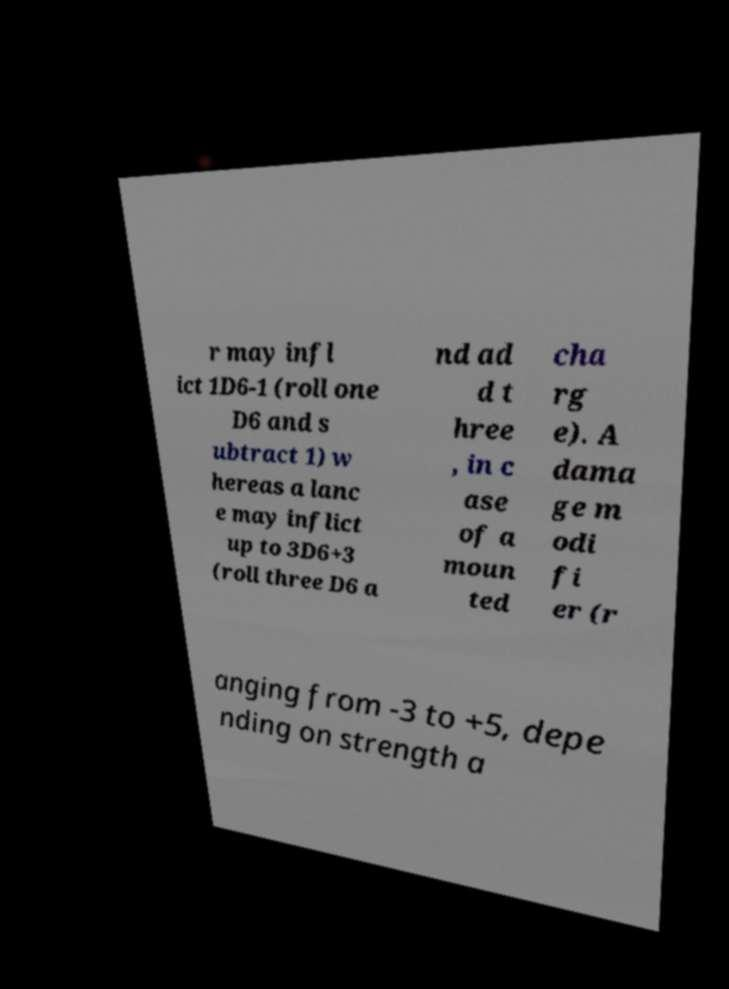Please read and relay the text visible in this image. What does it say? r may infl ict 1D6-1 (roll one D6 and s ubtract 1) w hereas a lanc e may inflict up to 3D6+3 (roll three D6 a nd ad d t hree , in c ase of a moun ted cha rg e). A dama ge m odi fi er (r anging from -3 to +5, depe nding on strength a 